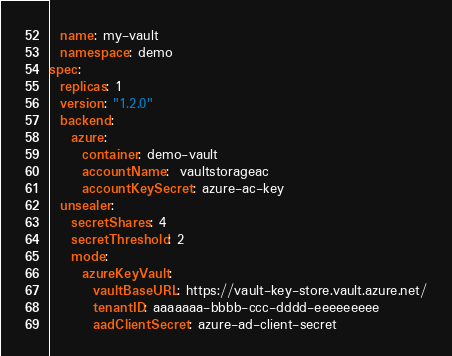Convert code to text. <code><loc_0><loc_0><loc_500><loc_500><_YAML_>  name: my-vault
  namespace: demo
spec:
  replicas: 1
  version: "1.2.0"
  backend:
    azure:
      container: demo-vault
      accountName:  vaultstorageac
      accountKeySecret: azure-ac-key
  unsealer:
    secretShares: 4
    secretThreshold: 2
    mode:
      azureKeyVault:
        vaultBaseURL: https://vault-key-store.vault.azure.net/
        tenantID: aaaaaaa-bbbb-ccc-dddd-eeeeeeeee
        aadClientSecret: azure-ad-client-secret
</code> 